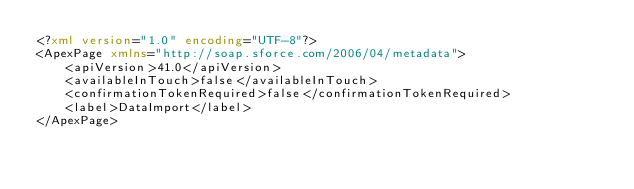Convert code to text. <code><loc_0><loc_0><loc_500><loc_500><_XML_><?xml version="1.0" encoding="UTF-8"?>
<ApexPage xmlns="http://soap.sforce.com/2006/04/metadata">
    <apiVersion>41.0</apiVersion>
    <availableInTouch>false</availableInTouch>
    <confirmationTokenRequired>false</confirmationTokenRequired>
    <label>DataImport</label>
</ApexPage>
</code> 